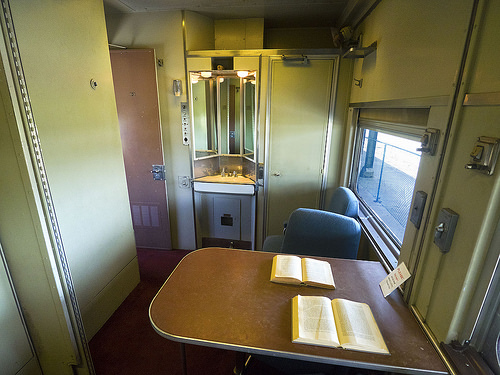<image>
Is there a book on the table? Yes. Looking at the image, I can see the book is positioned on top of the table, with the table providing support. Is there a chair to the right of the table? No. The chair is not to the right of the table. The horizontal positioning shows a different relationship. Is the book next to the sink? No. The book is not positioned next to the sink. They are located in different areas of the scene. 